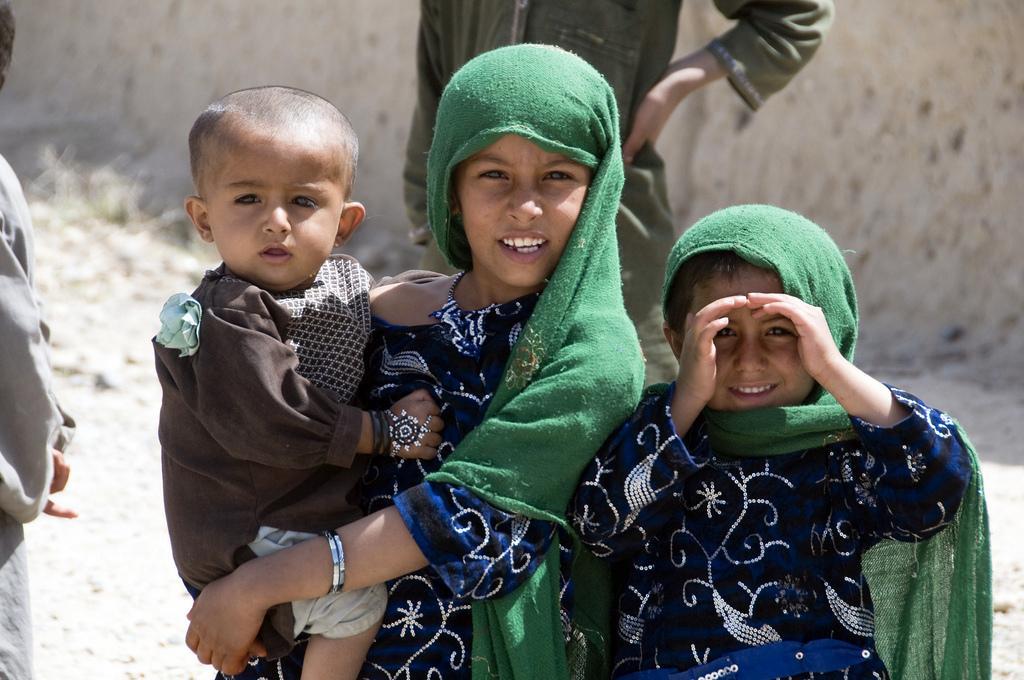Can you describe this image briefly? In this image, we can see kids wearing clothes. In the background, image is blurred. 